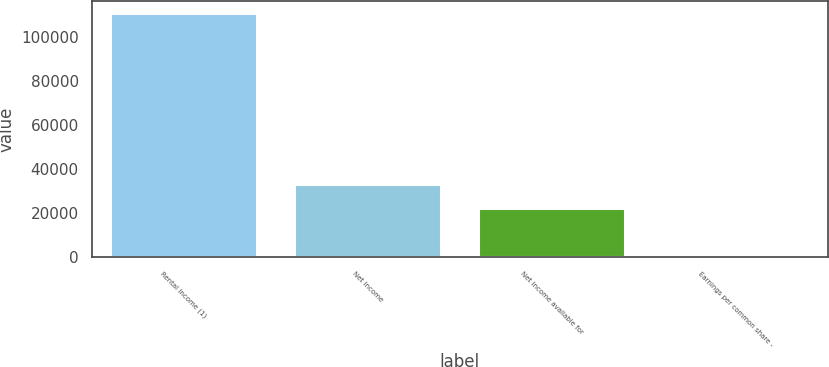Convert chart to OTSL. <chart><loc_0><loc_0><loc_500><loc_500><bar_chart><fcel>Rental income (1)<fcel>Net income<fcel>Net income available for<fcel>Earnings per common share -<nl><fcel>110511<fcel>33166.1<fcel>22115<fcel>0.41<nl></chart> 